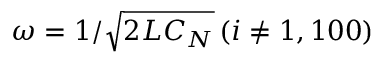<formula> <loc_0><loc_0><loc_500><loc_500>\omega = 1 / \sqrt { 2 L C _ { N } } \, ( i \neq 1 , 1 0 0 )</formula> 